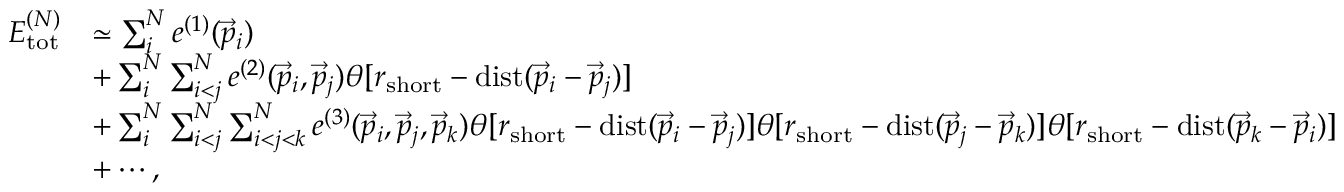<formula> <loc_0><loc_0><loc_500><loc_500>\begin{array} { r l } { E _ { t o t } ^ { ( N ) } } & { \simeq \sum _ { i } ^ { N } e ^ { ( 1 ) } ( \vec { p } _ { i } ) } \\ & { + \sum _ { i } ^ { N } \sum _ { i < j } ^ { N } e ^ { ( 2 ) } ( \vec { p } _ { i } , \vec { p } _ { j } ) \theta [ r _ { s h o r t } - d i s t ( \vec { p } _ { i } - \vec { p } _ { j } ) ] } \\ & { + \sum _ { i } ^ { N } \sum _ { i < j } ^ { N } \sum _ { i < j < k } ^ { N } e ^ { ( 3 ) } ( \vec { p } _ { i } , \vec { p } _ { j } , \vec { p } _ { k } ) \theta [ r _ { s h o r t } - d i s t ( \vec { p } _ { i } - \vec { p } _ { j } ) ] \theta [ r _ { s h o r t } - d i s t ( \vec { p } _ { j } - \vec { p } _ { k } ) ] \theta [ r _ { s h o r t } - d i s t ( \vec { p } _ { k } - \vec { p } _ { i } ) ] } \\ & { + \cdots , } \end{array}</formula> 